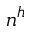<formula> <loc_0><loc_0><loc_500><loc_500>n ^ { h }</formula> 